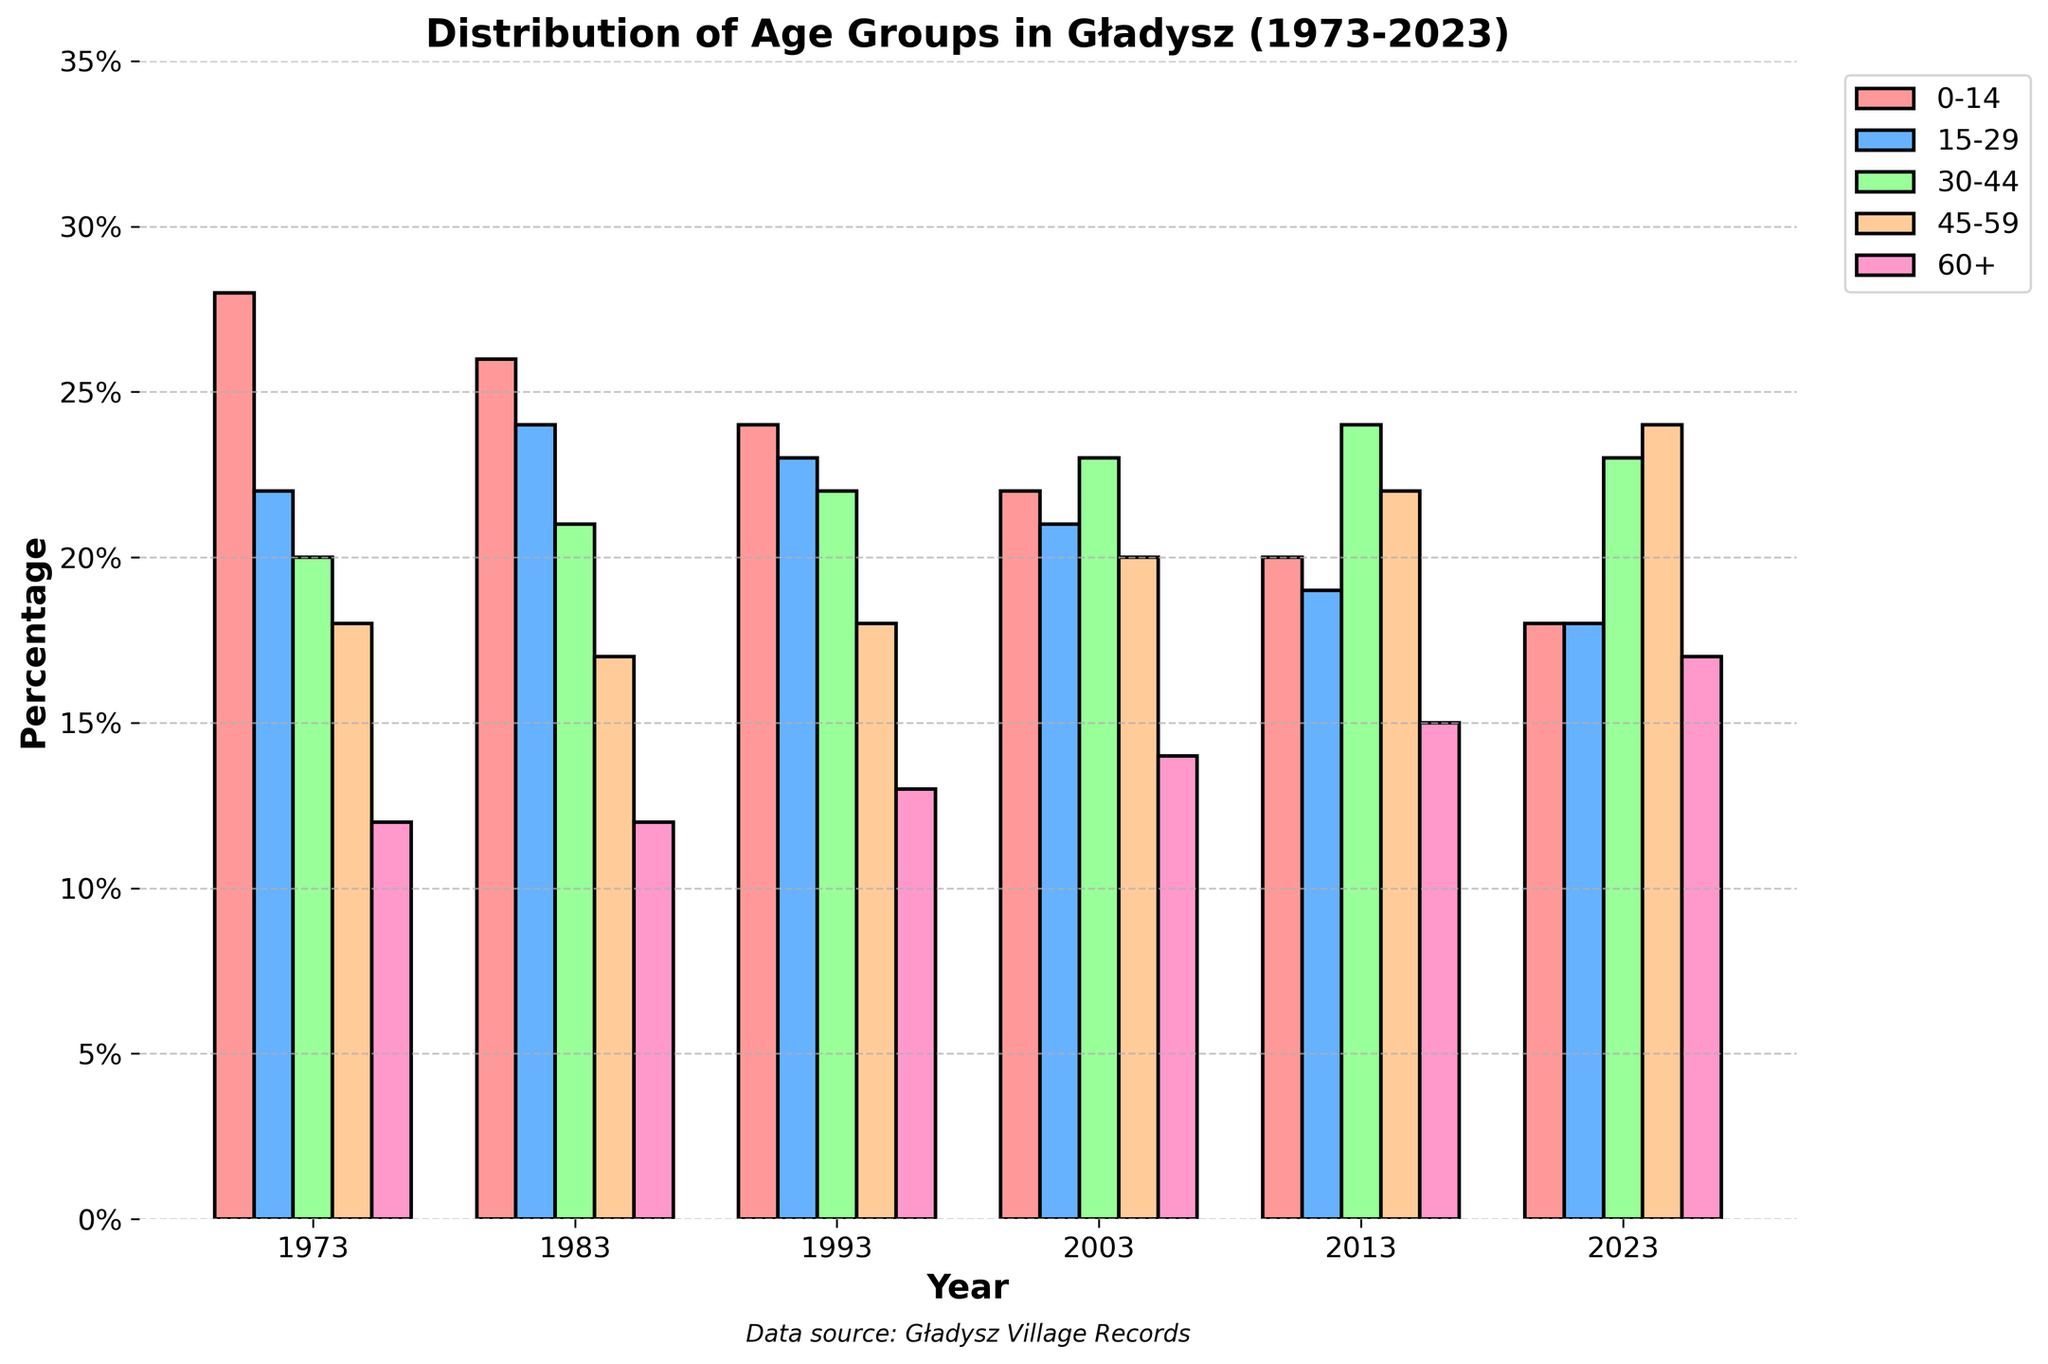What is the percentage of the 15-29 age group in 1993? Look at the bar labeled "1993" and identify the height of the bar for the 15-29 age group, which is the second color from the left. According to the legend, it corresponds to the 15-29 group.
Answer: 23% How has the percentage of the 0-14 age group changed from 1973 to 2023? Compare the heights of the bars labeled "0-14" in the years 1973 and 2023. The data indicates a decrease from 28% in 1973 to 18% in 2023.
Answer: Decreased by 10% Which age group has shown a consistent increase over the years? Analyze the change in the height of the bars for each age group over time. The 60+ age group has shown a consistent increase from 12% in 1973 to 17% in 2023.
Answer: 60+ In which year did the 30-44 age group have the highest percentage? Look at the bars for the 30-44 age group across all years and identify the tallest one. The highest percentage is in 2013.
Answer: 2013 What is the total percentage of people aged 30-59 in 2023? Sum the heights of the bars for the 30-44 and 45-59 age groups in 2023. These values are 23% for 30-44 and 24% for 45-59, summing up to 47%.
Answer: 47% How does the percentage of people aged 60+ in 2023 compare to 1983? Compare the heights of the bars for the 60+ age group in the years 2023 and 1983. The data shows an increase from 12% in 1983 to 17% in 2023.
Answer: Increased by 5% Which age group had the highest percentage in 1973? Identify the tallest bar in the year 1973. The highest percentage belongs to the 0-14 age group.
Answer: 0-14 By how much did the percentage of the 45-59 age group increase between 1973 and 2013? Subtract the percentage of the 45-59 age group in 1973 (18%) from that in 2013 (22%). The increase is 4%.
Answer: Increased by 4% What is the difference in percentage between the 0-14 and 60+ age groups in 2023? Subtract the percentage of the 60+ age group in 2023 (17%) from the 0-14 age group (18%). The difference is 1%.
Answer: 1% Was there ever a year where the 15-29 and 30-44 age groups had the same percentage? Compare the heights of the bars for the 15-29 and 30-44 age groups across all years, noting any year where the heights match. This happens in 2023, where both are 18% and 23%, respectively.
Answer: No 